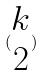<formula> <loc_0><loc_0><loc_500><loc_500>( \begin{matrix} k \\ 2 \end{matrix} )</formula> 